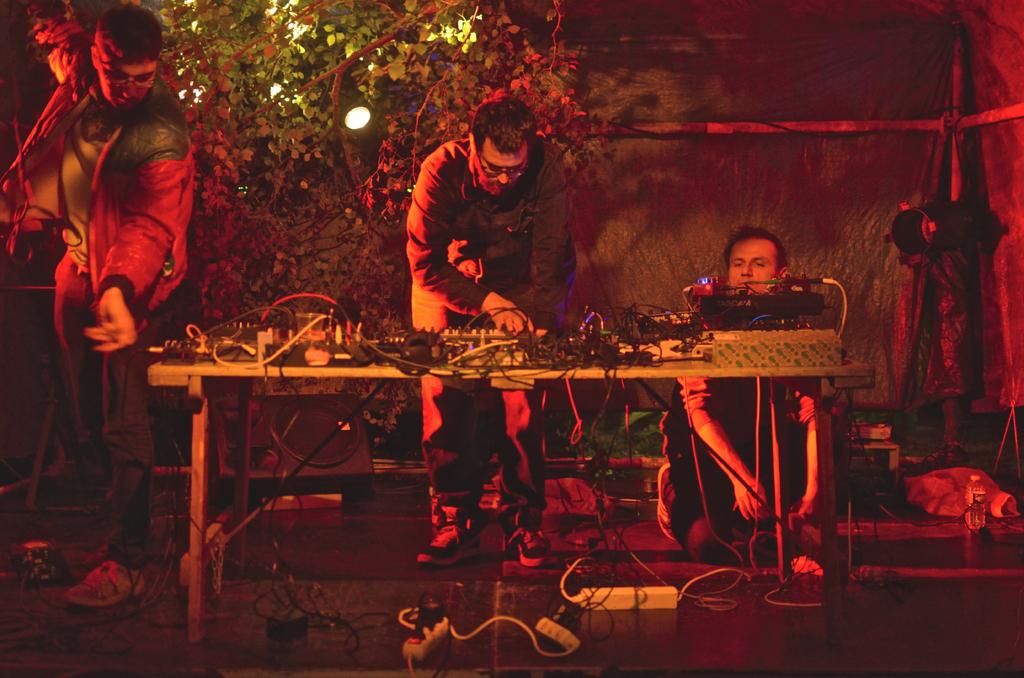What type of furniture can be seen in the image? There is a table in the image. What is placed on the table? There are electrical objects on the table. Are there any living beings visible in the image? Yes, there are people visible in the image. What can be observed about the lighting in the image? There is light in the image. What type of plant is present in the image? There is a plant in the image. What is the background of the image composed of? There is a wall in the image. What type of vessel is being used to hold hope in the image? There is no vessel holding hope in the image; the provided facts do not mention anything about hope or a vessel. 